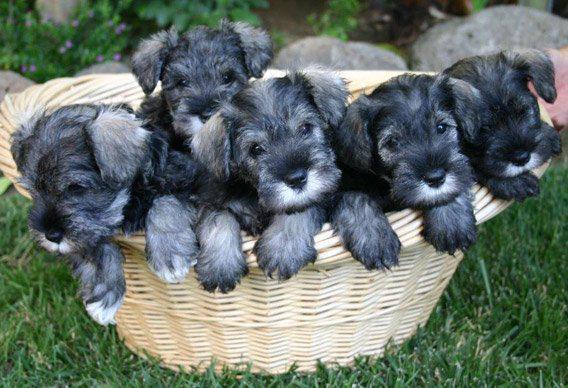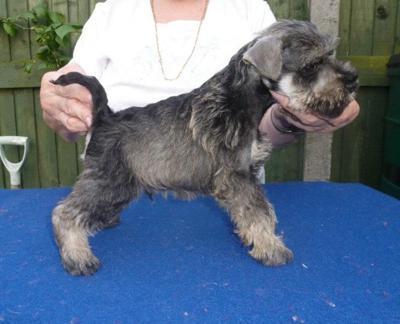The first image is the image on the left, the second image is the image on the right. For the images shown, is this caption "There are at least 4 black, gray and white puppies." true? Answer yes or no. Yes. The first image is the image on the left, the second image is the image on the right. Assess this claim about the two images: "There are four dogs total.". Correct or not? Answer yes or no. No. 